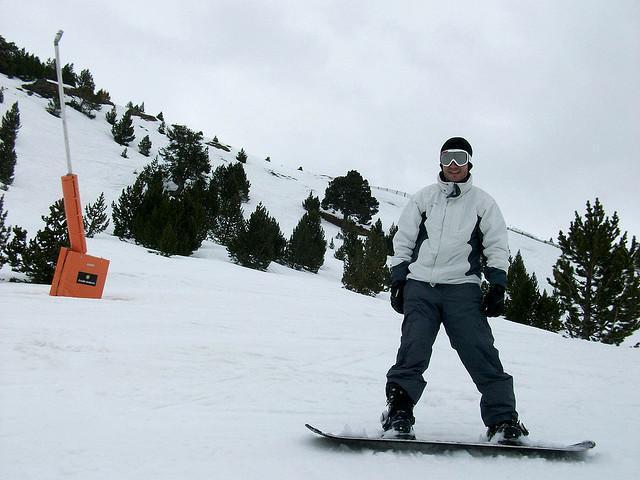How many people can you see?
Give a very brief answer. 1. 